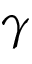Convert formula to latex. <formula><loc_0><loc_0><loc_500><loc_500>\gamma</formula> 